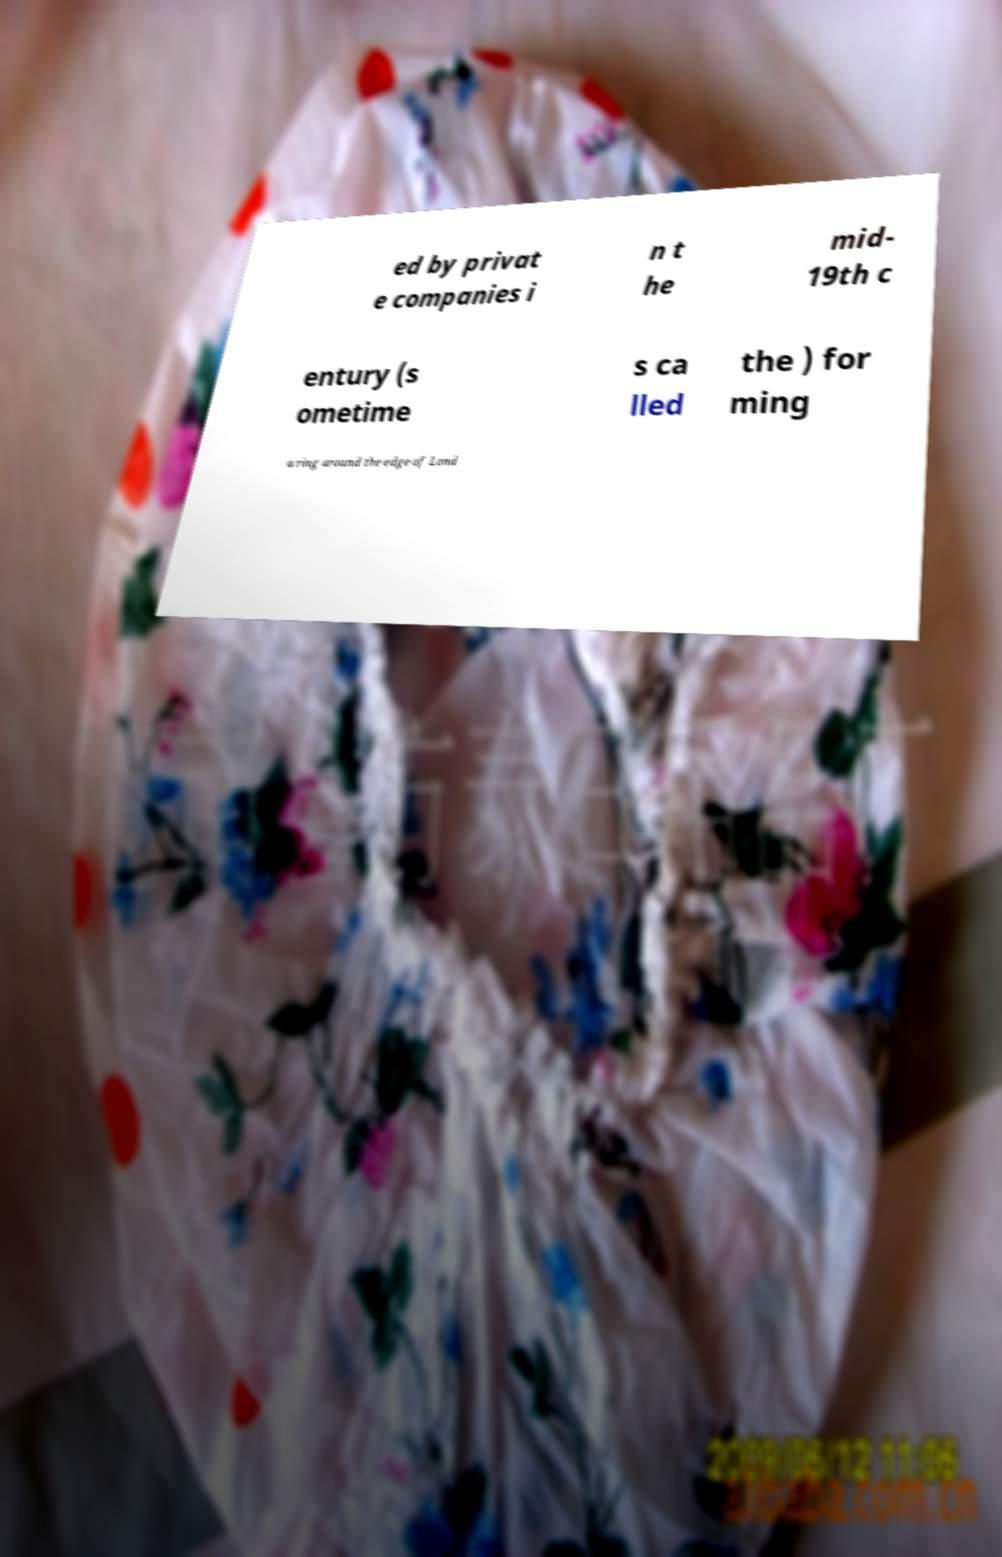For documentation purposes, I need the text within this image transcribed. Could you provide that? ed by privat e companies i n t he mid- 19th c entury (s ometime s ca lled the ) for ming a ring around the edge of Lond 